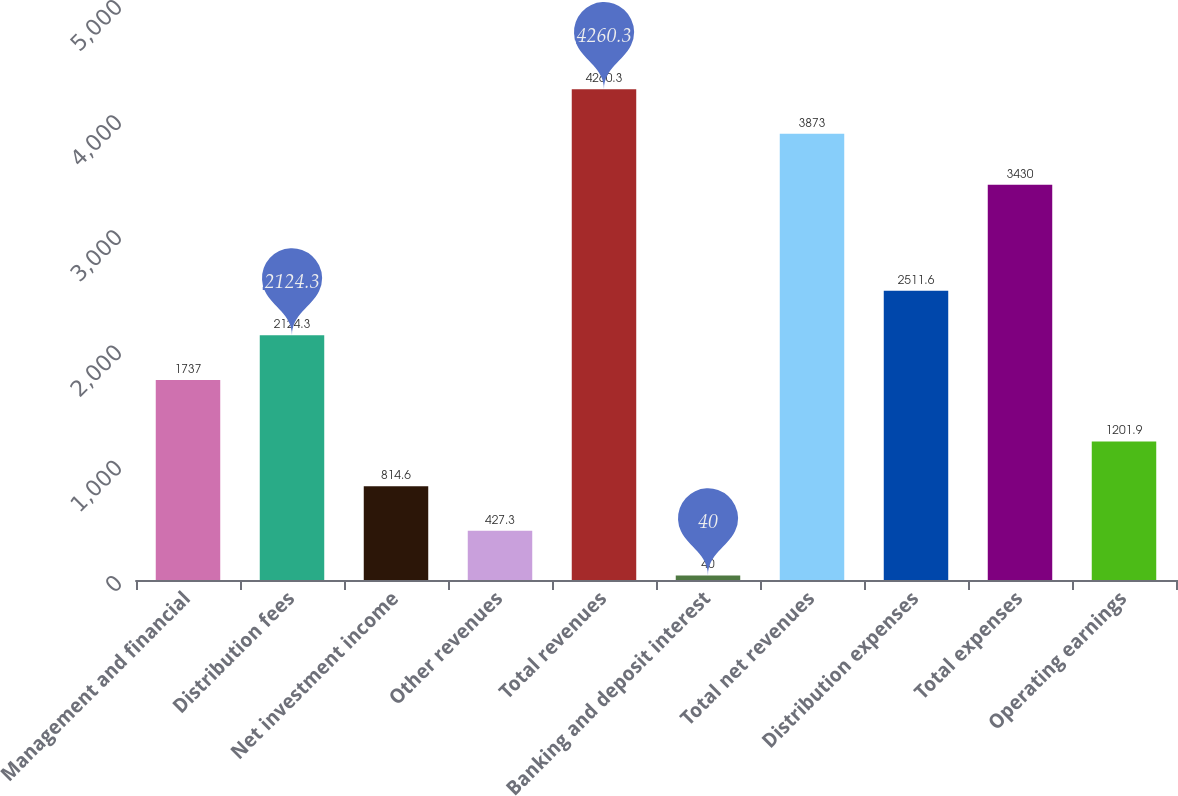Convert chart. <chart><loc_0><loc_0><loc_500><loc_500><bar_chart><fcel>Management and financial<fcel>Distribution fees<fcel>Net investment income<fcel>Other revenues<fcel>Total revenues<fcel>Banking and deposit interest<fcel>Total net revenues<fcel>Distribution expenses<fcel>Total expenses<fcel>Operating earnings<nl><fcel>1737<fcel>2124.3<fcel>814.6<fcel>427.3<fcel>4260.3<fcel>40<fcel>3873<fcel>2511.6<fcel>3430<fcel>1201.9<nl></chart> 